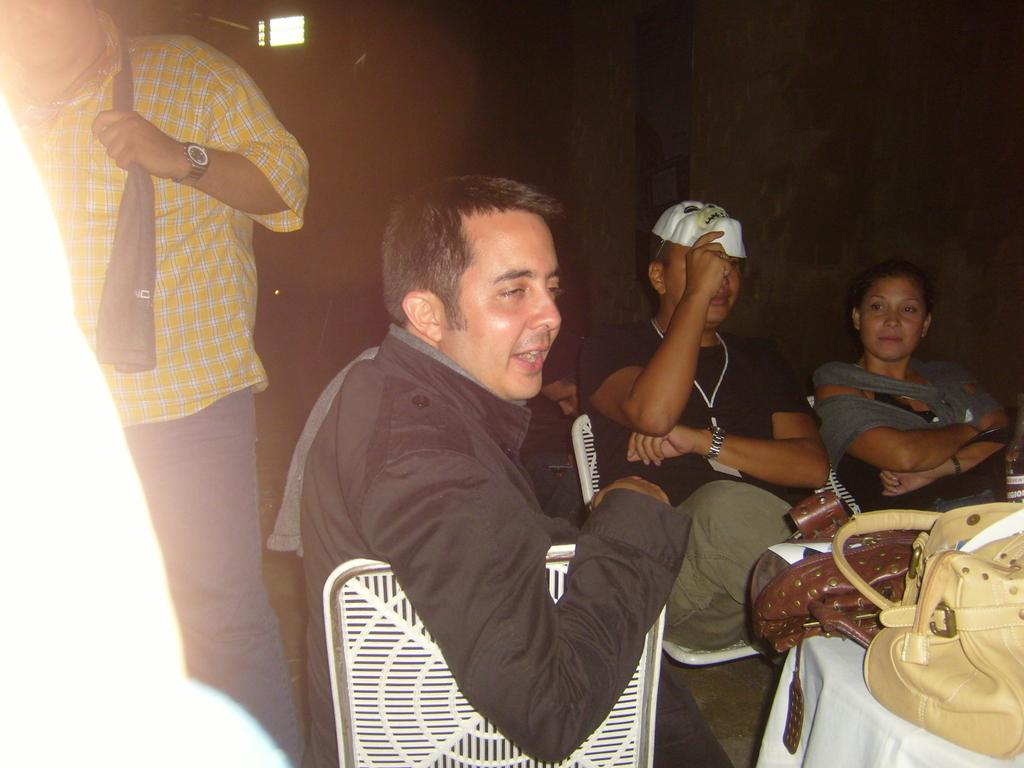What is happening in the foreground of the image? There are people in the foreground of the image. Can you describe the positions of the people in the image? Some people are standing, while others are sitting. What is on the table in the image? There are bags on a table. What can be seen in the background of the image? There is a window in the background of the image. What type of club is being used by the people in the image? There is no club present in the image; the people are simply standing or sitting. 